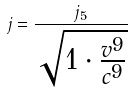Convert formula to latex. <formula><loc_0><loc_0><loc_500><loc_500>j = \frac { j _ { 5 } } { \sqrt { 1 \cdot \frac { v ^ { 9 } } { c ^ { 9 } } } }</formula> 